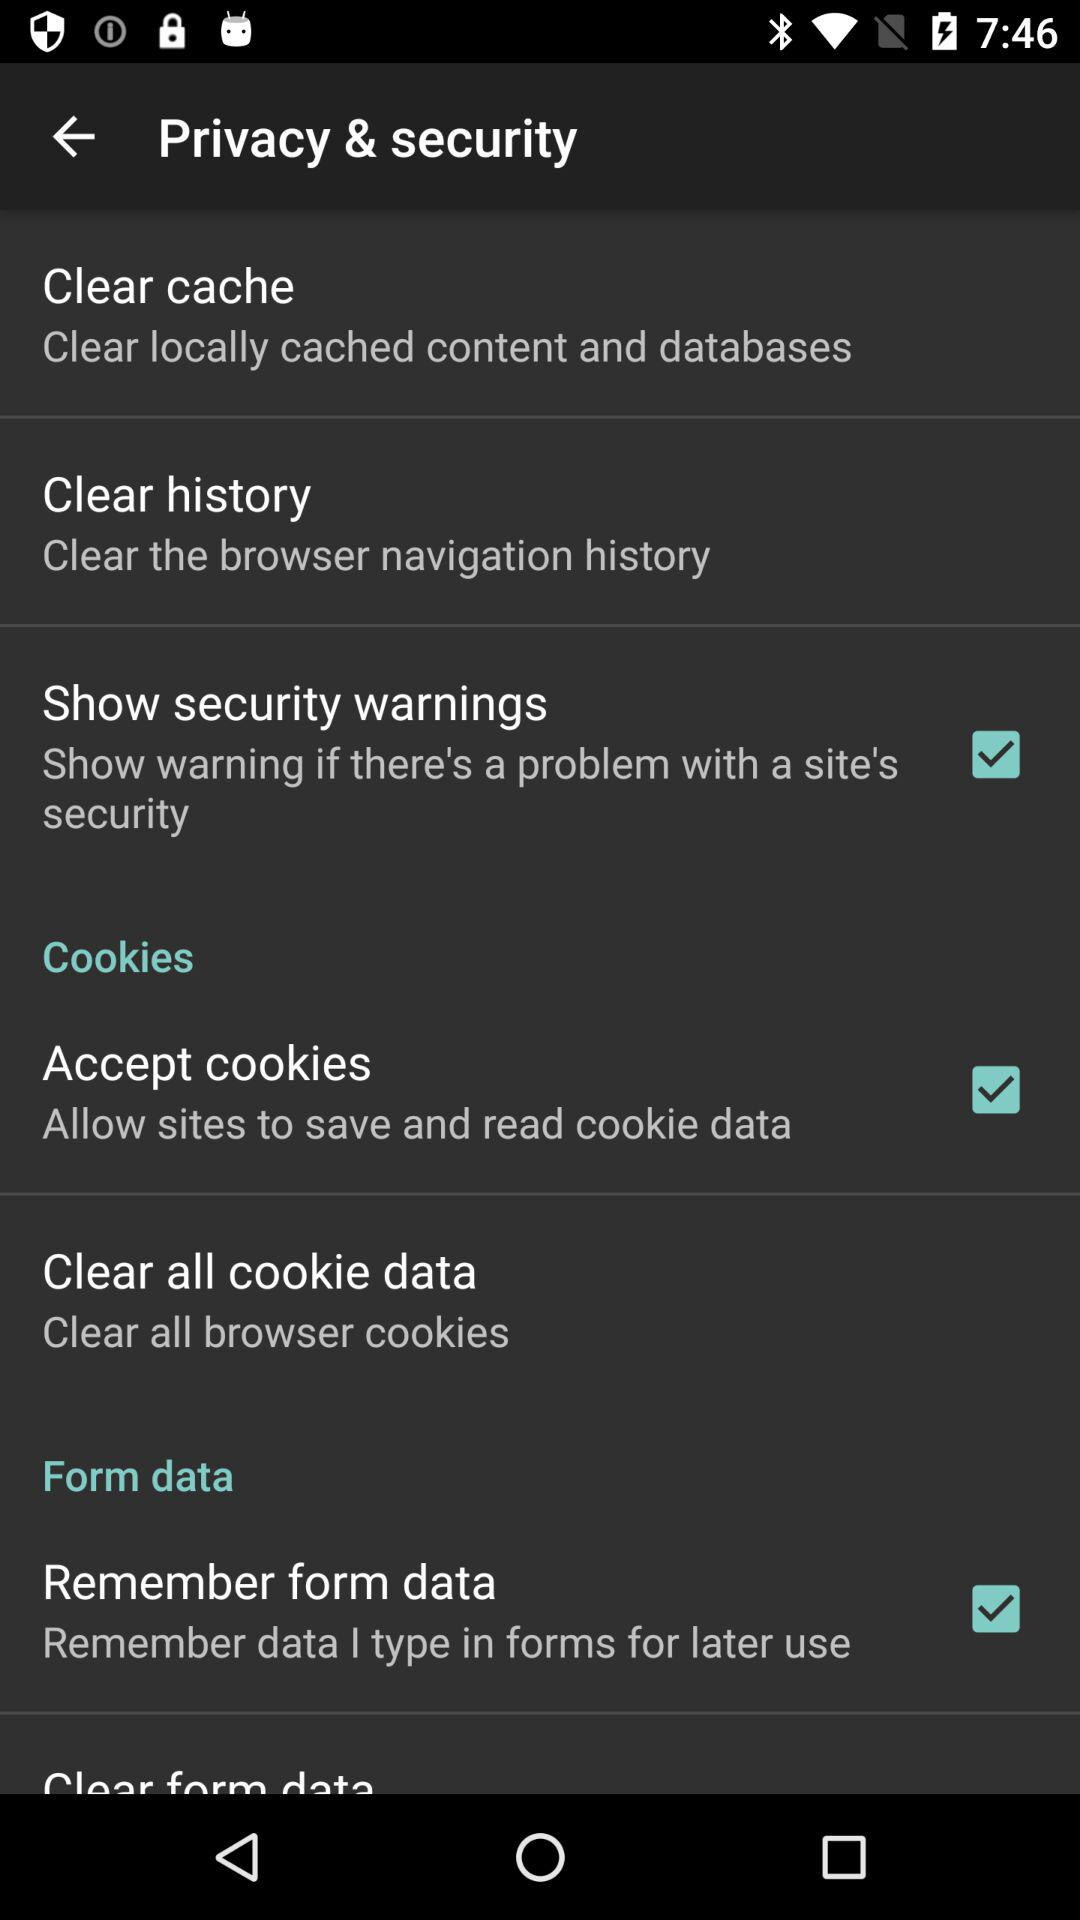How many items can be cleared with the clear cache and clear history options?
Answer the question using a single word or phrase. 2 